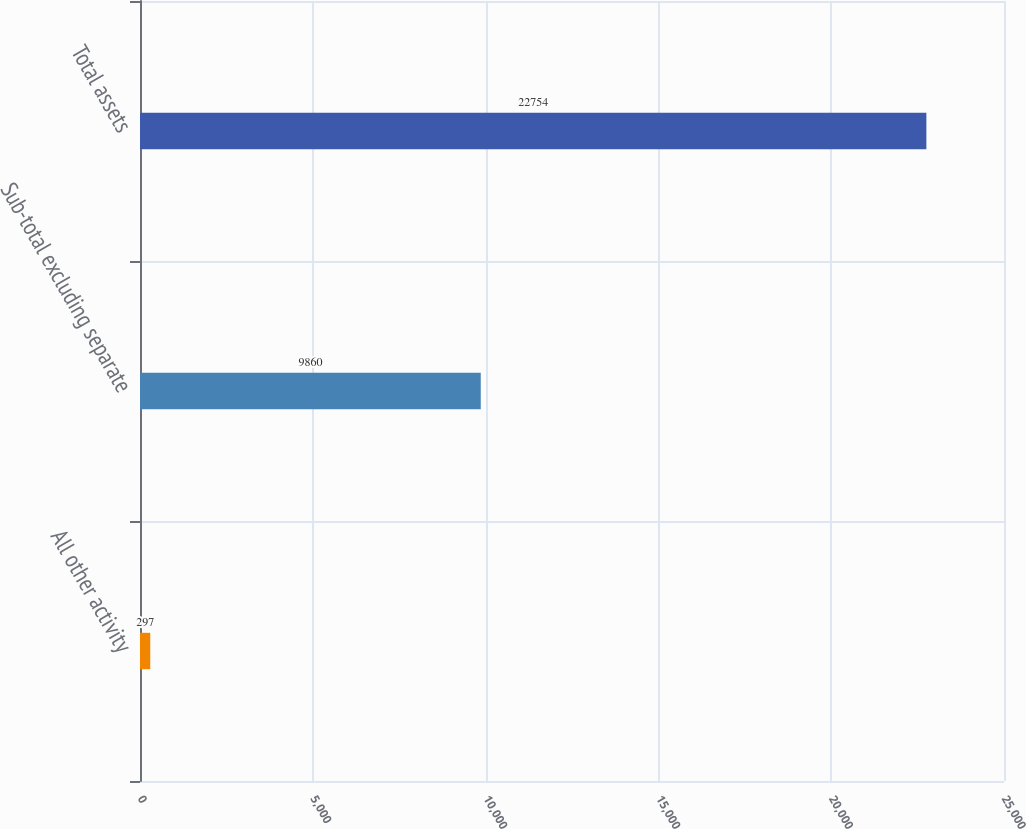Convert chart to OTSL. <chart><loc_0><loc_0><loc_500><loc_500><bar_chart><fcel>All other activity<fcel>Sub-total excluding separate<fcel>Total assets<nl><fcel>297<fcel>9860<fcel>22754<nl></chart> 